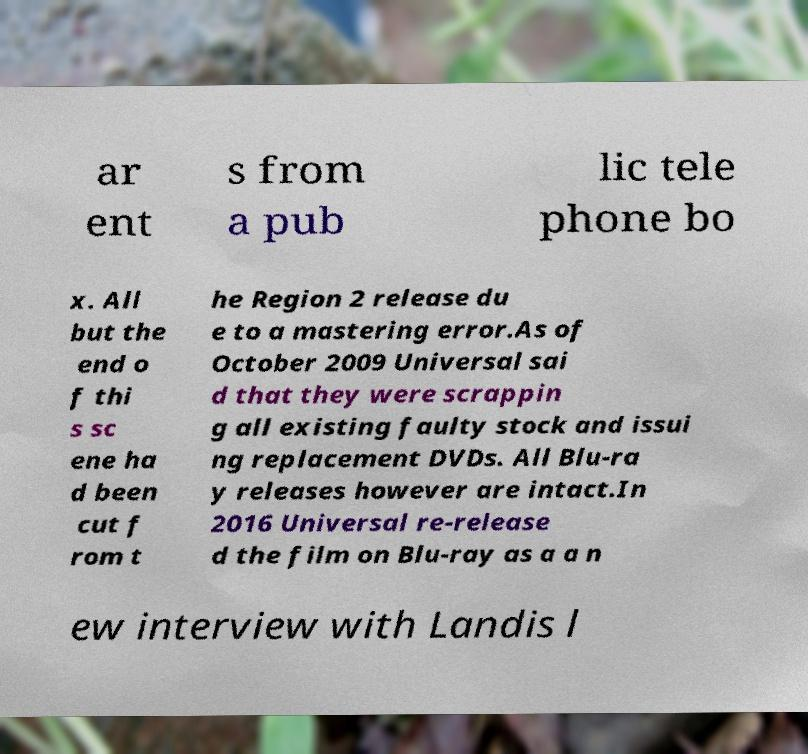Please identify and transcribe the text found in this image. ar ent s from a pub lic tele phone bo x. All but the end o f thi s sc ene ha d been cut f rom t he Region 2 release du e to a mastering error.As of October 2009 Universal sai d that they were scrappin g all existing faulty stock and issui ng replacement DVDs. All Blu-ra y releases however are intact.In 2016 Universal re-release d the film on Blu-ray as a a n ew interview with Landis l 